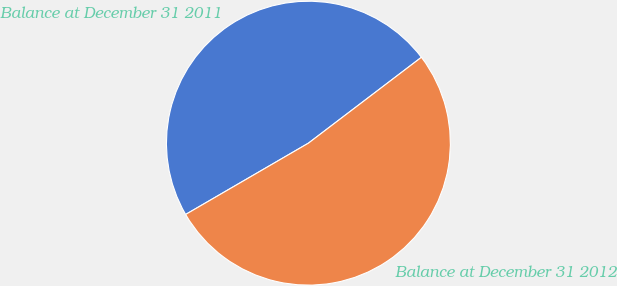Convert chart to OTSL. <chart><loc_0><loc_0><loc_500><loc_500><pie_chart><fcel>Balance at December 31 2011<fcel>Balance at December 31 2012<nl><fcel>48.03%<fcel>51.97%<nl></chart> 